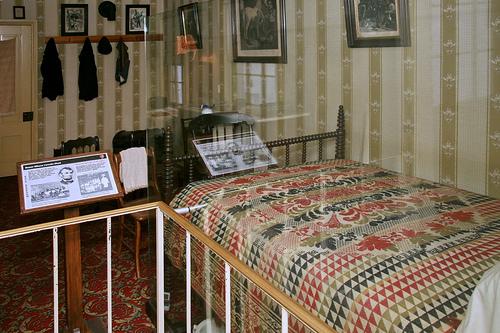How many pictures are in the room?
Concise answer only. 8. What president is on the display?
Concise answer only. Lincoln. What is the pattern on the wall?
Answer briefly. Stripes. 